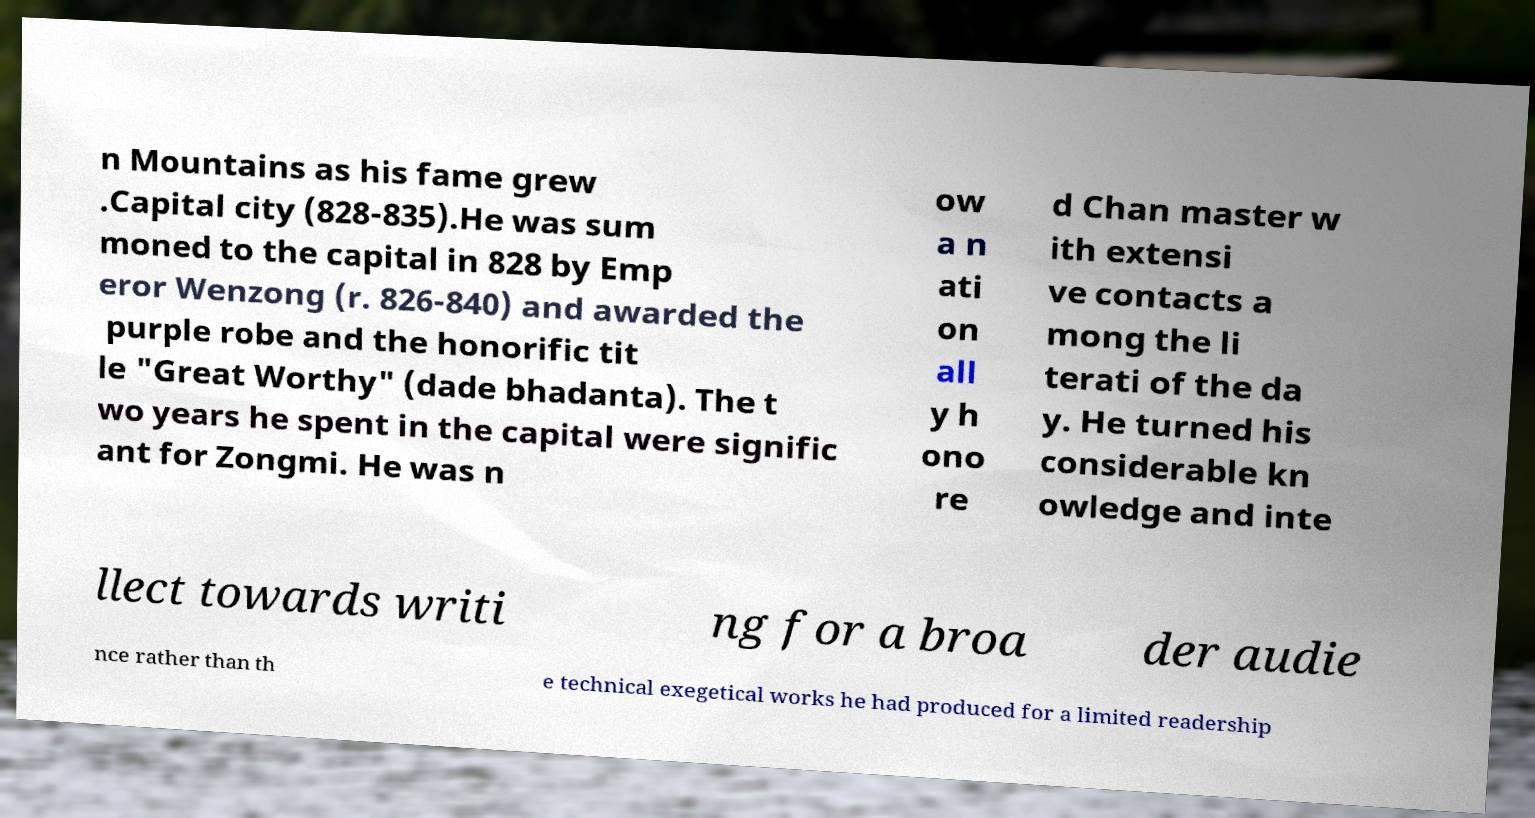Please identify and transcribe the text found in this image. n Mountains as his fame grew .Capital city (828-835).He was sum moned to the capital in 828 by Emp eror Wenzong (r. 826-840) and awarded the purple robe and the honorific tit le "Great Worthy" (dade bhadanta). The t wo years he spent in the capital were signific ant for Zongmi. He was n ow a n ati on all y h ono re d Chan master w ith extensi ve contacts a mong the li terati of the da y. He turned his considerable kn owledge and inte llect towards writi ng for a broa der audie nce rather than th e technical exegetical works he had produced for a limited readership 